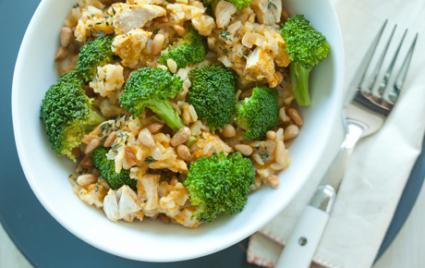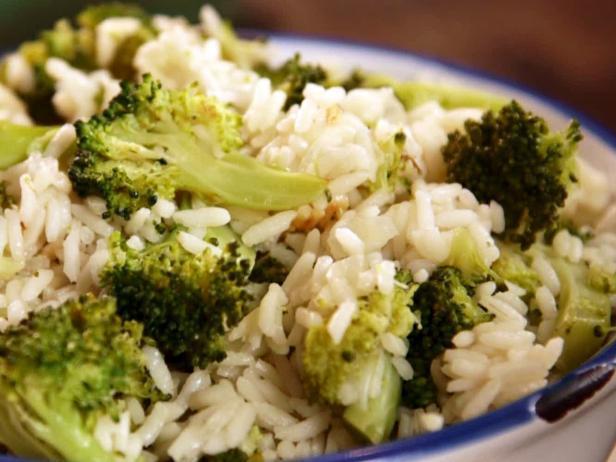The first image is the image on the left, the second image is the image on the right. Given the left and right images, does the statement "Some of the food in one image is in a spoon." hold true? Answer yes or no. No. 